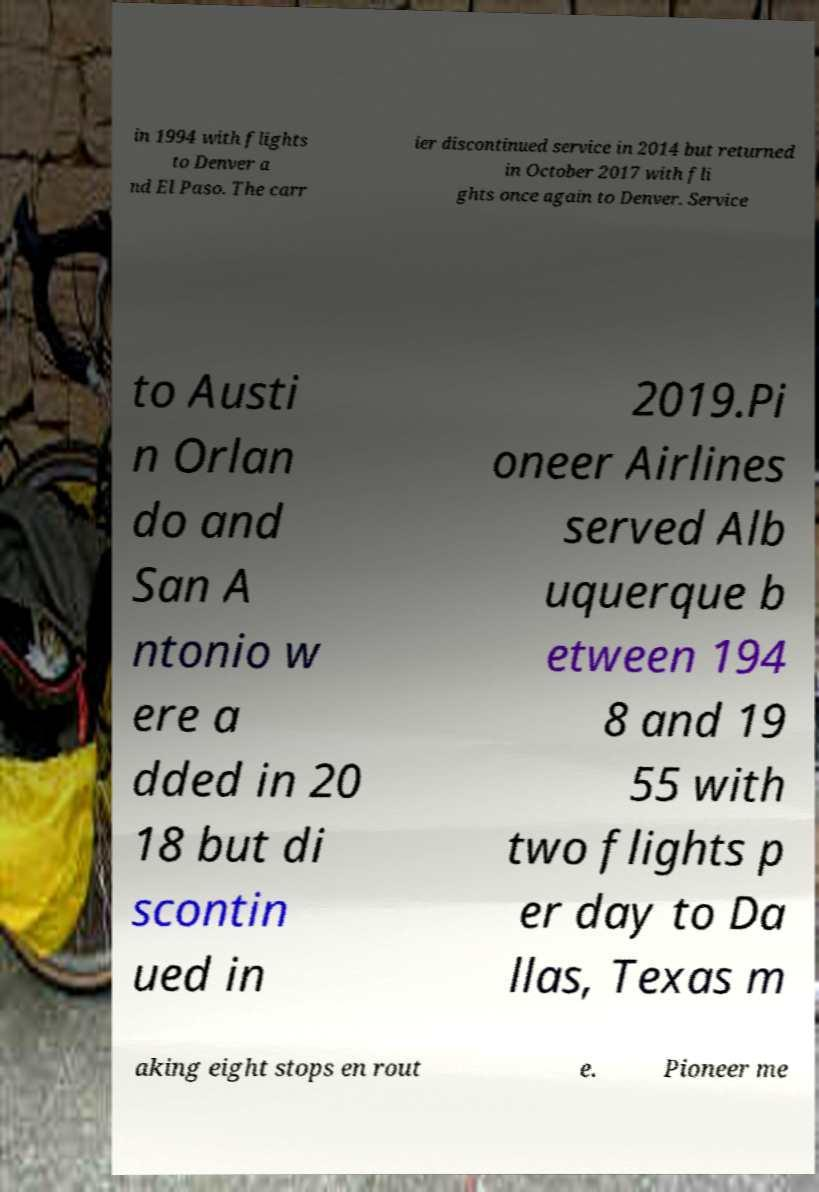Could you extract and type out the text from this image? in 1994 with flights to Denver a nd El Paso. The carr ier discontinued service in 2014 but returned in October 2017 with fli ghts once again to Denver. Service to Austi n Orlan do and San A ntonio w ere a dded in 20 18 but di scontin ued in 2019.Pi oneer Airlines served Alb uquerque b etween 194 8 and 19 55 with two flights p er day to Da llas, Texas m aking eight stops en rout e. Pioneer me 